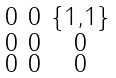<formula> <loc_0><loc_0><loc_500><loc_500>\begin{smallmatrix} 0 & 0 & \{ 1 , 1 \} \\ 0 & 0 & 0 \\ 0 & 0 & 0 \end{smallmatrix}</formula> 